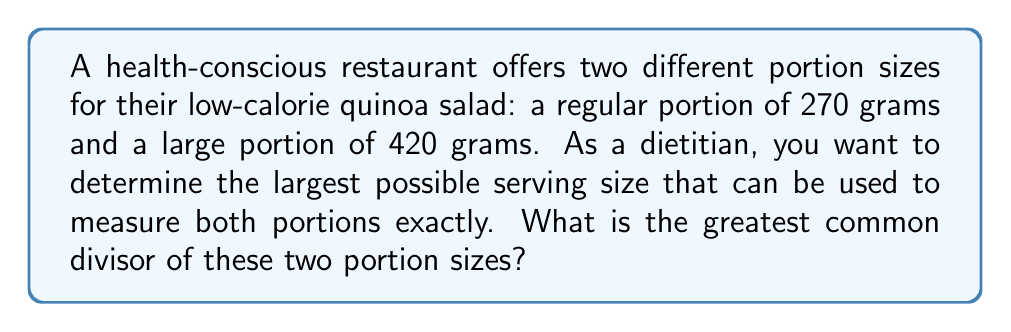Provide a solution to this math problem. To find the greatest common divisor (GCD) of 270 and 420, we can use the Euclidean algorithm:

1) First, set up the equation:
   $420 = 1 \times 270 + 150$

2) Now, divide 270 by 150:
   $270 = 1 \times 150 + 120$

3) Divide 150 by 120:
   $150 = 1 \times 120 + 30$

4) Divide 120 by 30:
   $120 = 4 \times 30 + 0$

The process stops when we get a remainder of 0. The last non-zero remainder is the GCD.

Therefore, $GCD(270, 420) = 30$

We can verify this result:
$270 = 9 \times 30$
$420 = 14 \times 30$

From a dietitian's perspective, this means that both portion sizes can be measured exactly using a 30-gram serving size, which allows for precise portion control and calorie counting.
Answer: The greatest common divisor of 270 and 420 is 30 grams. 